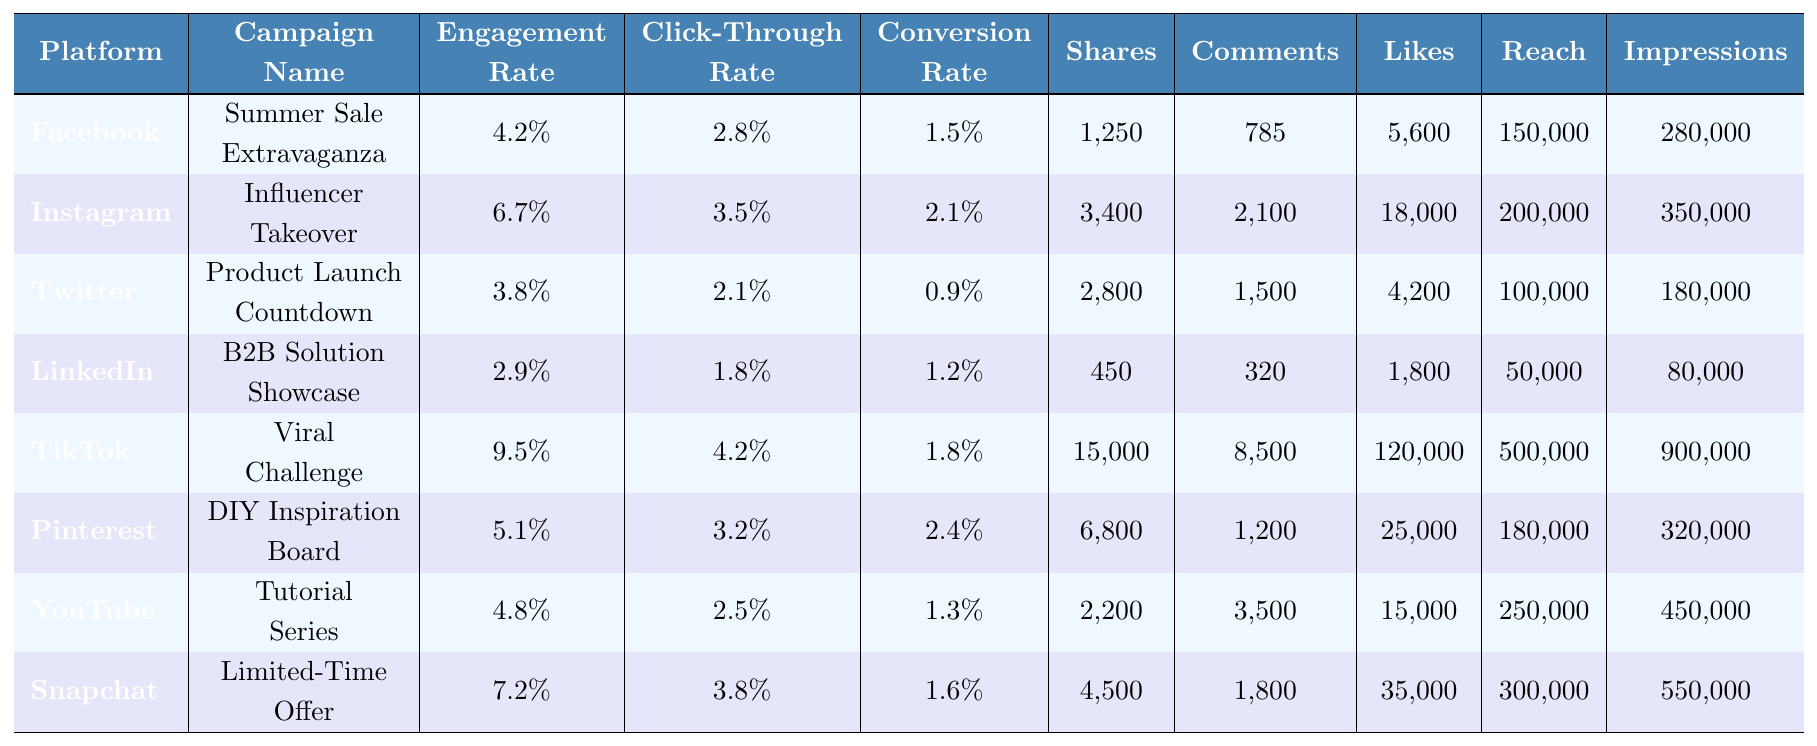What is the engagement rate for the TikTok campaign? The table lists the engagement rate for TikTok under the "Engagement Rate" column, which is 9.5%.
Answer: 9.5% Which campaign had the highest number of shares? Looking at the "Shares" column, the TikTok campaign had the highest number with 15,000 shares.
Answer: TikTok campaign What is the average conversion rate for all platforms? To find the average, add the conversion rates (1.5 + 2.1 + 0.9 + 1.2 + 1.8 + 2.4 + 1.3 + 1.6) = 12.8% then divide by 8 (total campaigns), giving an average of 1.6%.
Answer: 1.6% Did any campaign have a click-through rate above 4%? By checking the "Click-Through Rate" column, only the TikTok campaign has a click-through rate of 4.2%.
Answer: Yes Which platform had the lowest reach and what was the value? In the "Reach" column, LinkedIn shows the lowest reach at 50,000.
Answer: LinkedIn, 50,000 What is the total number of likes across all campaigns? Adding the likes: (5,600 + 18,000 + 4,200 + 1,800 + 120,000 + 25,000 + 15,000 + 35,000) equals 209,600.
Answer: 209,600 Is the engagement rate for the Instagram campaign higher than the average engagement rate of all campaigns? The average engagement rate is (4.2 + 6.7 + 3.8 + 2.9 + 9.5 + 5.1 + 4.8 + 7.2) = 44.6% divided by 8 gives an average of 5.575%. Since Instagram's engagement rate is 6.7%, it is indeed higher.
Answer: Yes Which campaign had the highest reach and what was that reach? The reach of the TikTok campaign is the highest at 500,000 in the "Reach" column.
Answer: TikTok campaign, 500,000 What is the difference in engagement rates between the highest and lowest campaigns? The highest engagement rate is TikTok's 9.5% and the lowest is LinkedIn's 2.9%. The difference is 9.5% - 2.9% = 6.6%.
Answer: 6.6% Are there more comments on the Snapchat campaign than on the Facebook campaign? Snapchat has 1,800 comments and Facebook has 785 comments. Since 1,800 is greater than 785, the answer is yes.
Answer: Yes 